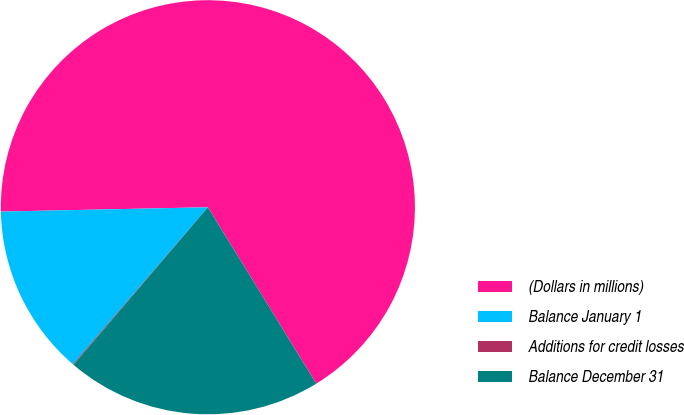Convert chart. <chart><loc_0><loc_0><loc_500><loc_500><pie_chart><fcel>(Dollars in millions)<fcel>Balance January 1<fcel>Additions for credit losses<fcel>Balance December 31<nl><fcel>66.56%<fcel>13.36%<fcel>0.07%<fcel>20.01%<nl></chart> 